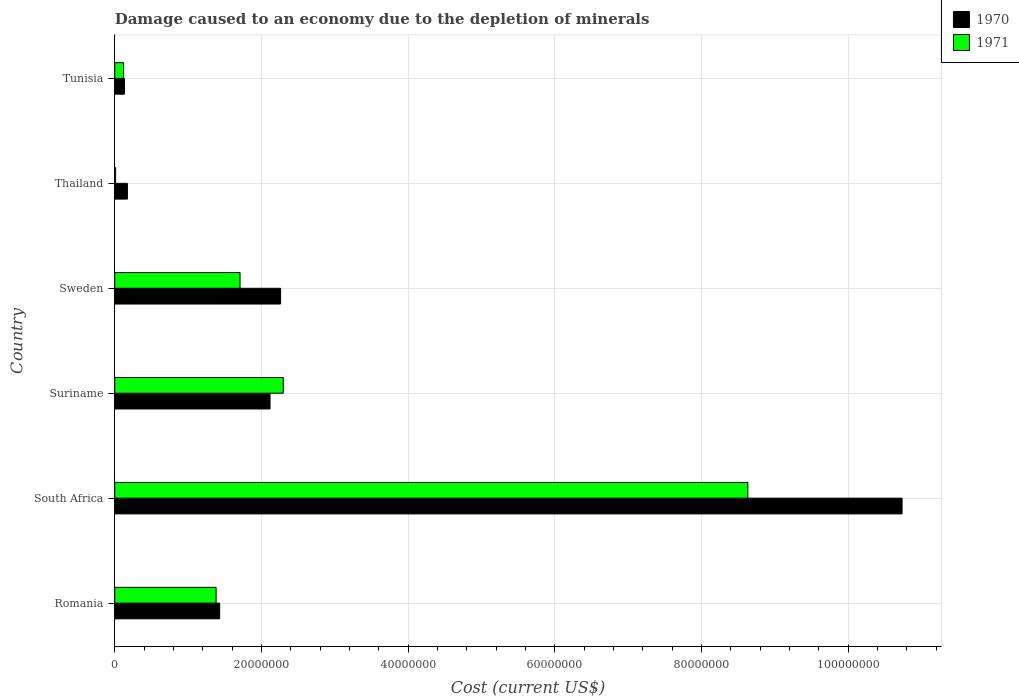Are the number of bars per tick equal to the number of legend labels?
Your answer should be very brief. Yes. How many bars are there on the 6th tick from the top?
Your response must be concise. 2. How many bars are there on the 5th tick from the bottom?
Keep it short and to the point. 2. What is the label of the 5th group of bars from the top?
Your answer should be very brief. South Africa. In how many cases, is the number of bars for a given country not equal to the number of legend labels?
Ensure brevity in your answer.  0. What is the cost of damage caused due to the depletion of minerals in 1970 in Romania?
Your answer should be very brief. 1.43e+07. Across all countries, what is the maximum cost of damage caused due to the depletion of minerals in 1971?
Offer a terse response. 8.63e+07. Across all countries, what is the minimum cost of damage caused due to the depletion of minerals in 1971?
Your answer should be compact. 1.21e+05. In which country was the cost of damage caused due to the depletion of minerals in 1970 maximum?
Your answer should be very brief. South Africa. In which country was the cost of damage caused due to the depletion of minerals in 1971 minimum?
Give a very brief answer. Thailand. What is the total cost of damage caused due to the depletion of minerals in 1970 in the graph?
Keep it short and to the point. 1.69e+08. What is the difference between the cost of damage caused due to the depletion of minerals in 1971 in South Africa and that in Tunisia?
Give a very brief answer. 8.51e+07. What is the difference between the cost of damage caused due to the depletion of minerals in 1970 in Thailand and the cost of damage caused due to the depletion of minerals in 1971 in Tunisia?
Offer a terse response. 5.13e+05. What is the average cost of damage caused due to the depletion of minerals in 1970 per country?
Offer a terse response. 2.81e+07. What is the difference between the cost of damage caused due to the depletion of minerals in 1971 and cost of damage caused due to the depletion of minerals in 1970 in Sweden?
Offer a very short reply. -5.53e+06. What is the ratio of the cost of damage caused due to the depletion of minerals in 1971 in Suriname to that in Sweden?
Make the answer very short. 1.35. Is the cost of damage caused due to the depletion of minerals in 1970 in Suriname less than that in Thailand?
Ensure brevity in your answer.  No. What is the difference between the highest and the second highest cost of damage caused due to the depletion of minerals in 1970?
Your answer should be compact. 8.47e+07. What is the difference between the highest and the lowest cost of damage caused due to the depletion of minerals in 1971?
Your answer should be compact. 8.62e+07. In how many countries, is the cost of damage caused due to the depletion of minerals in 1971 greater than the average cost of damage caused due to the depletion of minerals in 1971 taken over all countries?
Your response must be concise. 1. Is the sum of the cost of damage caused due to the depletion of minerals in 1970 in South Africa and Sweden greater than the maximum cost of damage caused due to the depletion of minerals in 1971 across all countries?
Your answer should be very brief. Yes. Are all the bars in the graph horizontal?
Your answer should be compact. Yes. How many countries are there in the graph?
Provide a short and direct response. 6. What is the difference between two consecutive major ticks on the X-axis?
Keep it short and to the point. 2.00e+07. Are the values on the major ticks of X-axis written in scientific E-notation?
Provide a succinct answer. No. Does the graph contain any zero values?
Ensure brevity in your answer.  No. Does the graph contain grids?
Your answer should be very brief. Yes. How are the legend labels stacked?
Provide a short and direct response. Vertical. What is the title of the graph?
Your response must be concise. Damage caused to an economy due to the depletion of minerals. What is the label or title of the X-axis?
Ensure brevity in your answer.  Cost (current US$). What is the Cost (current US$) in 1970 in Romania?
Make the answer very short. 1.43e+07. What is the Cost (current US$) of 1971 in Romania?
Keep it short and to the point. 1.38e+07. What is the Cost (current US$) of 1970 in South Africa?
Ensure brevity in your answer.  1.07e+08. What is the Cost (current US$) in 1971 in South Africa?
Your response must be concise. 8.63e+07. What is the Cost (current US$) in 1970 in Suriname?
Provide a succinct answer. 2.12e+07. What is the Cost (current US$) of 1971 in Suriname?
Provide a succinct answer. 2.30e+07. What is the Cost (current US$) in 1970 in Sweden?
Ensure brevity in your answer.  2.26e+07. What is the Cost (current US$) of 1971 in Sweden?
Provide a succinct answer. 1.71e+07. What is the Cost (current US$) in 1970 in Thailand?
Your response must be concise. 1.72e+06. What is the Cost (current US$) in 1971 in Thailand?
Keep it short and to the point. 1.21e+05. What is the Cost (current US$) of 1970 in Tunisia?
Make the answer very short. 1.33e+06. What is the Cost (current US$) in 1971 in Tunisia?
Provide a short and direct response. 1.21e+06. Across all countries, what is the maximum Cost (current US$) of 1970?
Your response must be concise. 1.07e+08. Across all countries, what is the maximum Cost (current US$) in 1971?
Ensure brevity in your answer.  8.63e+07. Across all countries, what is the minimum Cost (current US$) in 1970?
Give a very brief answer. 1.33e+06. Across all countries, what is the minimum Cost (current US$) of 1971?
Your answer should be compact. 1.21e+05. What is the total Cost (current US$) of 1970 in the graph?
Provide a short and direct response. 1.69e+08. What is the total Cost (current US$) in 1971 in the graph?
Keep it short and to the point. 1.42e+08. What is the difference between the Cost (current US$) in 1970 in Romania and that in South Africa?
Provide a short and direct response. -9.31e+07. What is the difference between the Cost (current US$) in 1971 in Romania and that in South Africa?
Ensure brevity in your answer.  -7.25e+07. What is the difference between the Cost (current US$) of 1970 in Romania and that in Suriname?
Give a very brief answer. -6.87e+06. What is the difference between the Cost (current US$) in 1971 in Romania and that in Suriname?
Your answer should be compact. -9.16e+06. What is the difference between the Cost (current US$) in 1970 in Romania and that in Sweden?
Give a very brief answer. -8.31e+06. What is the difference between the Cost (current US$) in 1971 in Romania and that in Sweden?
Make the answer very short. -3.26e+06. What is the difference between the Cost (current US$) of 1970 in Romania and that in Thailand?
Your answer should be compact. 1.26e+07. What is the difference between the Cost (current US$) of 1971 in Romania and that in Thailand?
Give a very brief answer. 1.37e+07. What is the difference between the Cost (current US$) in 1970 in Romania and that in Tunisia?
Your response must be concise. 1.30e+07. What is the difference between the Cost (current US$) of 1971 in Romania and that in Tunisia?
Give a very brief answer. 1.26e+07. What is the difference between the Cost (current US$) of 1970 in South Africa and that in Suriname?
Give a very brief answer. 8.62e+07. What is the difference between the Cost (current US$) of 1971 in South Africa and that in Suriname?
Give a very brief answer. 6.33e+07. What is the difference between the Cost (current US$) in 1970 in South Africa and that in Sweden?
Ensure brevity in your answer.  8.47e+07. What is the difference between the Cost (current US$) of 1971 in South Africa and that in Sweden?
Give a very brief answer. 6.92e+07. What is the difference between the Cost (current US$) in 1970 in South Africa and that in Thailand?
Give a very brief answer. 1.06e+08. What is the difference between the Cost (current US$) of 1971 in South Africa and that in Thailand?
Your response must be concise. 8.62e+07. What is the difference between the Cost (current US$) in 1970 in South Africa and that in Tunisia?
Provide a succinct answer. 1.06e+08. What is the difference between the Cost (current US$) of 1971 in South Africa and that in Tunisia?
Keep it short and to the point. 8.51e+07. What is the difference between the Cost (current US$) of 1970 in Suriname and that in Sweden?
Make the answer very short. -1.44e+06. What is the difference between the Cost (current US$) of 1971 in Suriname and that in Sweden?
Your response must be concise. 5.90e+06. What is the difference between the Cost (current US$) of 1970 in Suriname and that in Thailand?
Your answer should be very brief. 1.94e+07. What is the difference between the Cost (current US$) of 1971 in Suriname and that in Thailand?
Offer a terse response. 2.29e+07. What is the difference between the Cost (current US$) of 1970 in Suriname and that in Tunisia?
Provide a short and direct response. 1.98e+07. What is the difference between the Cost (current US$) of 1971 in Suriname and that in Tunisia?
Offer a terse response. 2.18e+07. What is the difference between the Cost (current US$) of 1970 in Sweden and that in Thailand?
Provide a short and direct response. 2.09e+07. What is the difference between the Cost (current US$) in 1971 in Sweden and that in Thailand?
Your answer should be compact. 1.70e+07. What is the difference between the Cost (current US$) in 1970 in Sweden and that in Tunisia?
Keep it short and to the point. 2.13e+07. What is the difference between the Cost (current US$) in 1971 in Sweden and that in Tunisia?
Make the answer very short. 1.59e+07. What is the difference between the Cost (current US$) in 1970 in Thailand and that in Tunisia?
Offer a terse response. 3.98e+05. What is the difference between the Cost (current US$) of 1971 in Thailand and that in Tunisia?
Provide a short and direct response. -1.09e+06. What is the difference between the Cost (current US$) of 1970 in Romania and the Cost (current US$) of 1971 in South Africa?
Offer a terse response. -7.20e+07. What is the difference between the Cost (current US$) in 1970 in Romania and the Cost (current US$) in 1971 in Suriname?
Give a very brief answer. -8.68e+06. What is the difference between the Cost (current US$) in 1970 in Romania and the Cost (current US$) in 1971 in Sweden?
Provide a short and direct response. -2.78e+06. What is the difference between the Cost (current US$) of 1970 in Romania and the Cost (current US$) of 1971 in Thailand?
Ensure brevity in your answer.  1.42e+07. What is the difference between the Cost (current US$) in 1970 in Romania and the Cost (current US$) in 1971 in Tunisia?
Provide a short and direct response. 1.31e+07. What is the difference between the Cost (current US$) in 1970 in South Africa and the Cost (current US$) in 1971 in Suriname?
Make the answer very short. 8.44e+07. What is the difference between the Cost (current US$) in 1970 in South Africa and the Cost (current US$) in 1971 in Sweden?
Provide a succinct answer. 9.03e+07. What is the difference between the Cost (current US$) of 1970 in South Africa and the Cost (current US$) of 1971 in Thailand?
Offer a terse response. 1.07e+08. What is the difference between the Cost (current US$) of 1970 in South Africa and the Cost (current US$) of 1971 in Tunisia?
Your response must be concise. 1.06e+08. What is the difference between the Cost (current US$) of 1970 in Suriname and the Cost (current US$) of 1971 in Sweden?
Make the answer very short. 4.09e+06. What is the difference between the Cost (current US$) of 1970 in Suriname and the Cost (current US$) of 1971 in Thailand?
Keep it short and to the point. 2.11e+07. What is the difference between the Cost (current US$) of 1970 in Suriname and the Cost (current US$) of 1971 in Tunisia?
Provide a short and direct response. 2.00e+07. What is the difference between the Cost (current US$) in 1970 in Sweden and the Cost (current US$) in 1971 in Thailand?
Keep it short and to the point. 2.25e+07. What is the difference between the Cost (current US$) of 1970 in Sweden and the Cost (current US$) of 1971 in Tunisia?
Keep it short and to the point. 2.14e+07. What is the difference between the Cost (current US$) of 1970 in Thailand and the Cost (current US$) of 1971 in Tunisia?
Provide a short and direct response. 5.13e+05. What is the average Cost (current US$) of 1970 per country?
Offer a very short reply. 2.81e+07. What is the average Cost (current US$) in 1971 per country?
Ensure brevity in your answer.  2.36e+07. What is the difference between the Cost (current US$) in 1970 and Cost (current US$) in 1971 in Romania?
Your answer should be very brief. 4.85e+05. What is the difference between the Cost (current US$) of 1970 and Cost (current US$) of 1971 in South Africa?
Your response must be concise. 2.10e+07. What is the difference between the Cost (current US$) of 1970 and Cost (current US$) of 1971 in Suriname?
Provide a succinct answer. -1.81e+06. What is the difference between the Cost (current US$) of 1970 and Cost (current US$) of 1971 in Sweden?
Keep it short and to the point. 5.53e+06. What is the difference between the Cost (current US$) of 1970 and Cost (current US$) of 1971 in Thailand?
Make the answer very short. 1.60e+06. What is the difference between the Cost (current US$) of 1970 and Cost (current US$) of 1971 in Tunisia?
Your response must be concise. 1.16e+05. What is the ratio of the Cost (current US$) in 1970 in Romania to that in South Africa?
Offer a terse response. 0.13. What is the ratio of the Cost (current US$) of 1971 in Romania to that in South Africa?
Your response must be concise. 0.16. What is the ratio of the Cost (current US$) in 1970 in Romania to that in Suriname?
Make the answer very short. 0.68. What is the ratio of the Cost (current US$) of 1971 in Romania to that in Suriname?
Ensure brevity in your answer.  0.6. What is the ratio of the Cost (current US$) of 1970 in Romania to that in Sweden?
Provide a succinct answer. 0.63. What is the ratio of the Cost (current US$) of 1971 in Romania to that in Sweden?
Offer a very short reply. 0.81. What is the ratio of the Cost (current US$) of 1970 in Romania to that in Thailand?
Make the answer very short. 8.29. What is the ratio of the Cost (current US$) in 1971 in Romania to that in Thailand?
Give a very brief answer. 114.65. What is the ratio of the Cost (current US$) of 1970 in Romania to that in Tunisia?
Make the answer very short. 10.78. What is the ratio of the Cost (current US$) of 1971 in Romania to that in Tunisia?
Give a very brief answer. 11.41. What is the ratio of the Cost (current US$) in 1970 in South Africa to that in Suriname?
Make the answer very short. 5.07. What is the ratio of the Cost (current US$) of 1971 in South Africa to that in Suriname?
Offer a terse response. 3.76. What is the ratio of the Cost (current US$) in 1970 in South Africa to that in Sweden?
Offer a very short reply. 4.75. What is the ratio of the Cost (current US$) in 1971 in South Africa to that in Sweden?
Give a very brief answer. 5.05. What is the ratio of the Cost (current US$) of 1970 in South Africa to that in Thailand?
Your answer should be very brief. 62.25. What is the ratio of the Cost (current US$) of 1971 in South Africa to that in Thailand?
Offer a very short reply. 716.15. What is the ratio of the Cost (current US$) of 1970 in South Africa to that in Tunisia?
Your response must be concise. 80.9. What is the ratio of the Cost (current US$) of 1971 in South Africa to that in Tunisia?
Offer a very short reply. 71.26. What is the ratio of the Cost (current US$) in 1970 in Suriname to that in Sweden?
Provide a short and direct response. 0.94. What is the ratio of the Cost (current US$) of 1971 in Suriname to that in Sweden?
Offer a very short reply. 1.35. What is the ratio of the Cost (current US$) of 1970 in Suriname to that in Thailand?
Ensure brevity in your answer.  12.28. What is the ratio of the Cost (current US$) of 1971 in Suriname to that in Thailand?
Your response must be concise. 190.64. What is the ratio of the Cost (current US$) of 1970 in Suriname to that in Tunisia?
Offer a very short reply. 15.96. What is the ratio of the Cost (current US$) of 1971 in Suriname to that in Tunisia?
Make the answer very short. 18.97. What is the ratio of the Cost (current US$) of 1970 in Sweden to that in Thailand?
Keep it short and to the point. 13.11. What is the ratio of the Cost (current US$) in 1971 in Sweden to that in Thailand?
Offer a very short reply. 141.73. What is the ratio of the Cost (current US$) of 1970 in Sweden to that in Tunisia?
Your answer should be very brief. 17.04. What is the ratio of the Cost (current US$) of 1971 in Sweden to that in Tunisia?
Offer a very short reply. 14.1. What is the ratio of the Cost (current US$) of 1970 in Thailand to that in Tunisia?
Provide a short and direct response. 1.3. What is the ratio of the Cost (current US$) in 1971 in Thailand to that in Tunisia?
Make the answer very short. 0.1. What is the difference between the highest and the second highest Cost (current US$) in 1970?
Your answer should be very brief. 8.47e+07. What is the difference between the highest and the second highest Cost (current US$) of 1971?
Keep it short and to the point. 6.33e+07. What is the difference between the highest and the lowest Cost (current US$) of 1970?
Your answer should be very brief. 1.06e+08. What is the difference between the highest and the lowest Cost (current US$) in 1971?
Offer a terse response. 8.62e+07. 